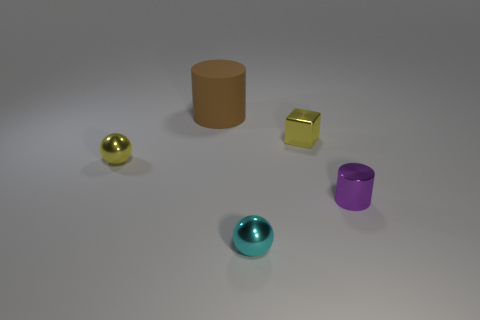Are the big object and the block made of the same material? Based on their appearance in the image, the big cylindrical object and the small block do not appear to be made of the same material. The cylinder has a matte finish suggesting a clay-like or plastic material, whereas the block has a reflective surface which is more characteristic of metal or polished stone. 